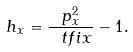<formula> <loc_0><loc_0><loc_500><loc_500>h _ { x } = \frac { p _ { x } ^ { 2 } } { \ t f i x } - 1 .</formula> 